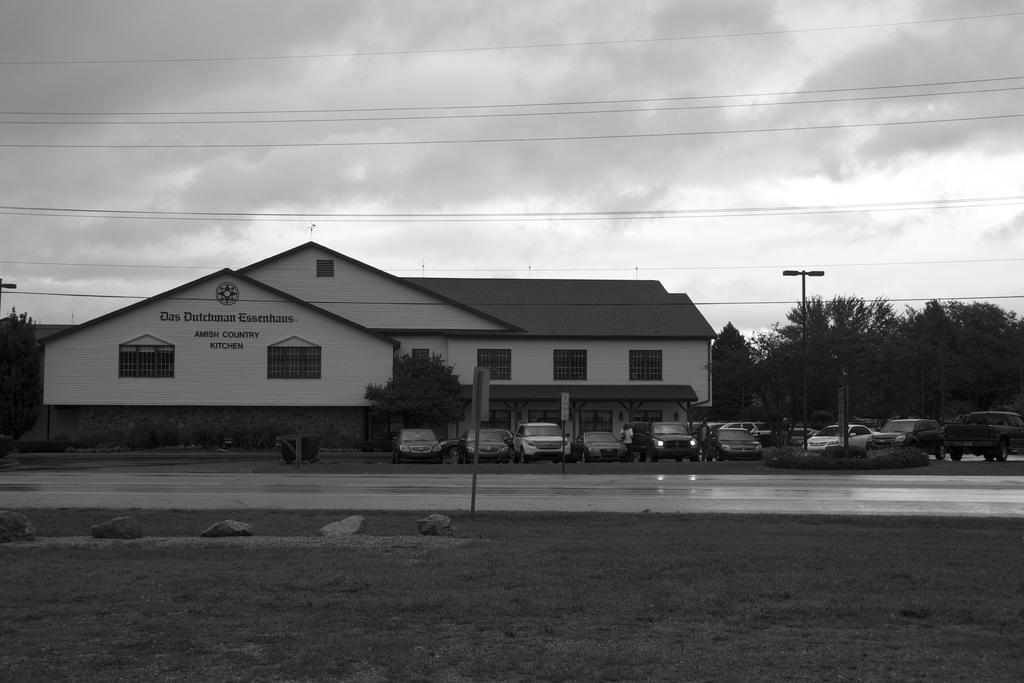Please provide a concise description of this image. This is a black and white image. In this image, on the ground there is grass and stones. Also there is a road. Near to that there is a board with pole. In the back there are many vehicles, buildings with name and windows. There are trees. Also there is a light pole. In the background there is sky with clouds. 